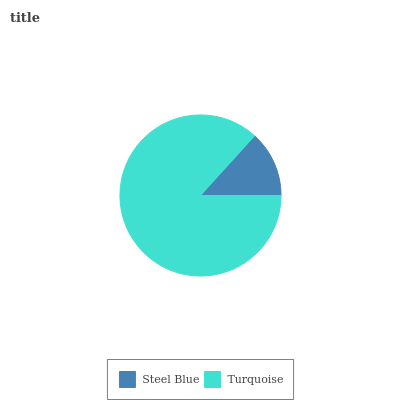Is Steel Blue the minimum?
Answer yes or no. Yes. Is Turquoise the maximum?
Answer yes or no. Yes. Is Turquoise the minimum?
Answer yes or no. No. Is Turquoise greater than Steel Blue?
Answer yes or no. Yes. Is Steel Blue less than Turquoise?
Answer yes or no. Yes. Is Steel Blue greater than Turquoise?
Answer yes or no. No. Is Turquoise less than Steel Blue?
Answer yes or no. No. Is Turquoise the high median?
Answer yes or no. Yes. Is Steel Blue the low median?
Answer yes or no. Yes. Is Steel Blue the high median?
Answer yes or no. No. Is Turquoise the low median?
Answer yes or no. No. 